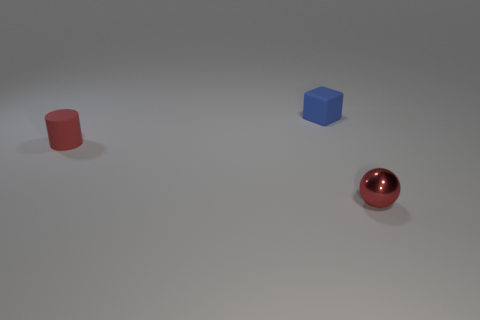There is a tiny sphere; is it the same color as the matte object that is in front of the blue matte cube?
Provide a succinct answer. Yes. What is the shape of the metallic thing that is the same color as the small cylinder?
Provide a short and direct response. Sphere. Do the tiny matte cylinder and the shiny sphere have the same color?
Offer a terse response. Yes. There is a metal ball that is the same color as the small matte cylinder; what size is it?
Ensure brevity in your answer.  Small. Is the red sphere made of the same material as the small block right of the red matte cylinder?
Give a very brief answer. No. What is the tiny red object that is on the right side of the tiny matte block made of?
Your response must be concise. Metal. Is the number of tiny red matte things that are left of the tiny red rubber thing the same as the number of big yellow blocks?
Ensure brevity in your answer.  Yes. The red thing that is right of the tiny rubber object behind the small rubber cylinder is made of what material?
Your response must be concise. Metal. There is a small thing that is both in front of the cube and right of the red rubber thing; what shape is it?
Make the answer very short. Sphere. Are there fewer metal balls on the left side of the blue thing than tiny shiny objects?
Provide a succinct answer. Yes. 